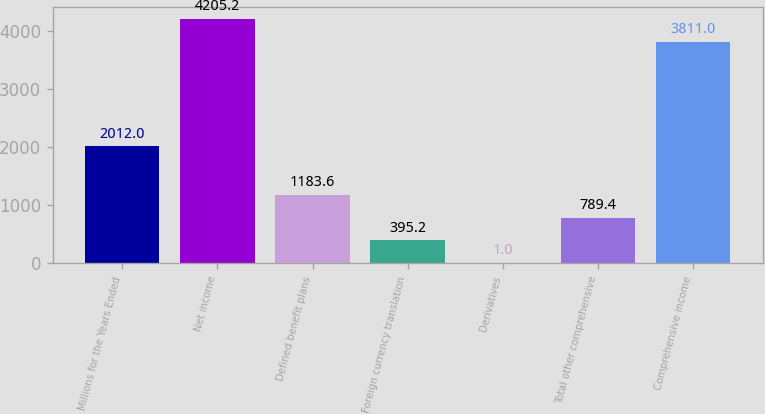Convert chart. <chart><loc_0><loc_0><loc_500><loc_500><bar_chart><fcel>Millions for the Years Ended<fcel>Net income<fcel>Defined benefit plans<fcel>Foreign currency translation<fcel>Derivatives<fcel>Total other comprehensive<fcel>Comprehensive income<nl><fcel>2012<fcel>4205.2<fcel>1183.6<fcel>395.2<fcel>1<fcel>789.4<fcel>3811<nl></chart> 